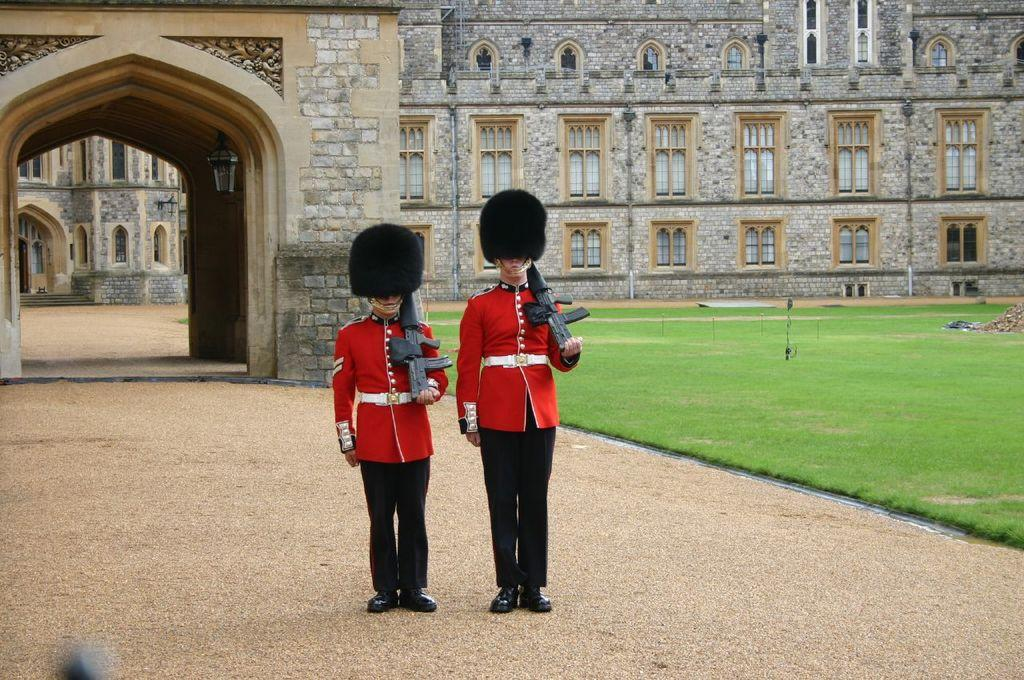What are the two people in the image doing? The two people in the image are standing and holding guns. What can be seen in the background of the image? There is a building, an arch, and grass in the background. Can you describe the building in the background? The building has windows. Where is the lamp located in the image? The lamp is attached to a wall. What type of vacation is the church offering in the image? There is no church or vacation mentioned in the image; it features two people holding guns and a background with a building, an arch, grass, and a lamp. 